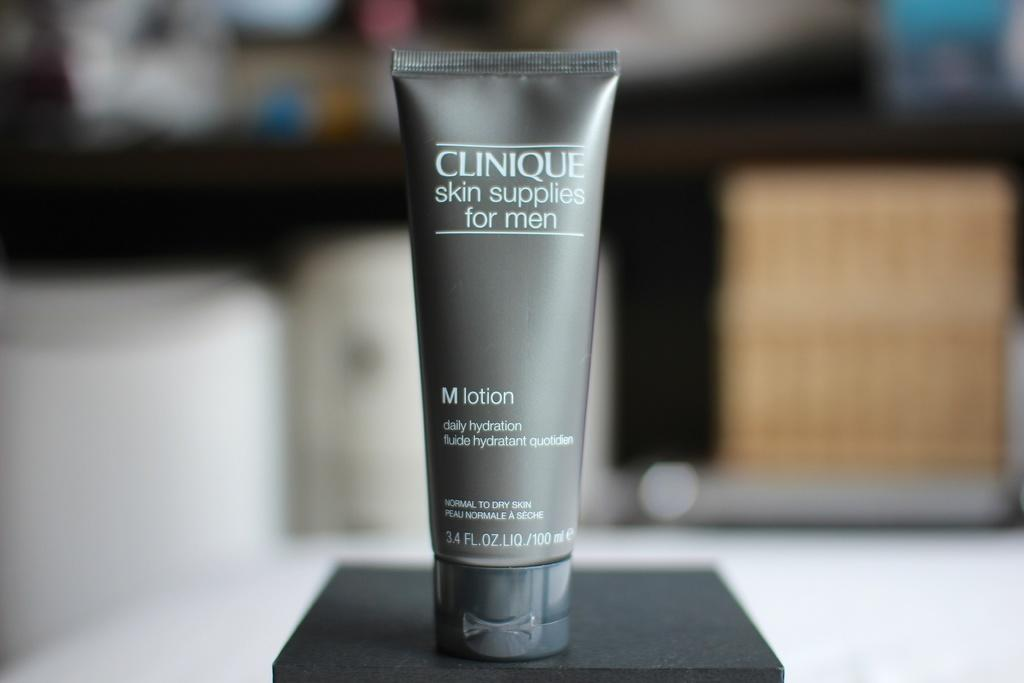What type of product is visible in the image? There is a lotion in the image. Who is the lotion intended for? The lotion is for men. Where is the lotion located in the image? The lotion is on a table. Can you see a trail leading to a camp in the image? There is no trail or camp present in the image; it only features a lotion for men on a table. 